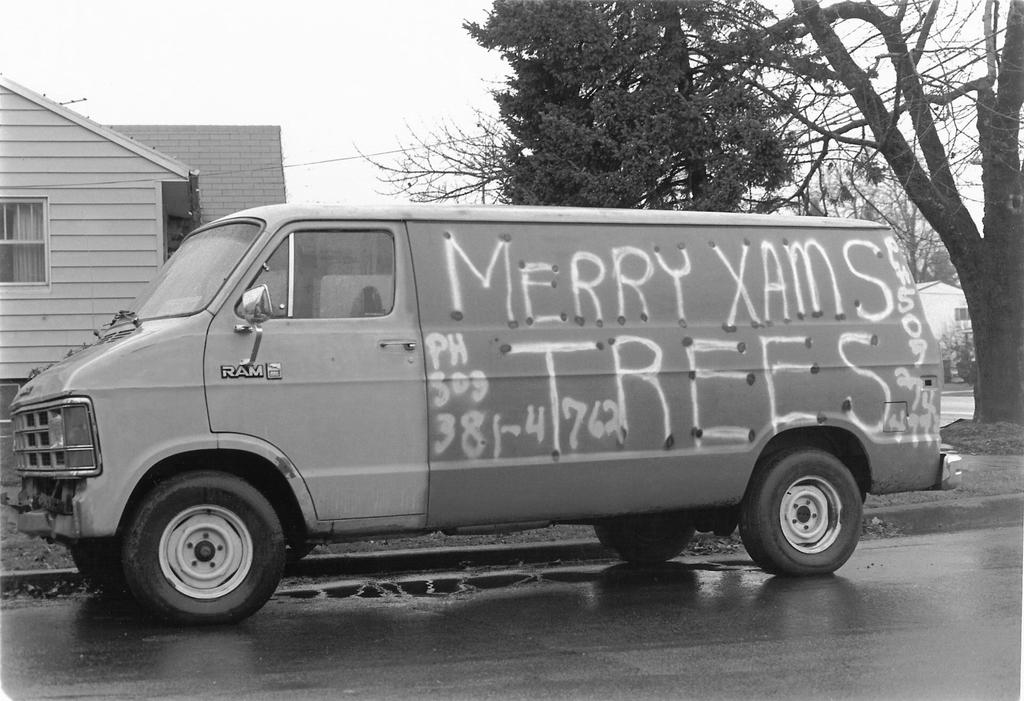What is the color scheme of the image? The image is black and white. What can be seen on the road in the image? There is a vehicle parked on the road. What structures are visible in the background of the image? There is a building, trees, and a house in the background. What part of the natural environment is visible in the image? The sky is visible in the image. Can you tell me how many frames are present in the image? There are no frames present in the image; it is a photograph or digital image without any visible frame. What type of toad can be seen hopping on the parked vehicle in the image? There is no toad present in the image; it only features a parked vehicle, a building, trees, a house, and the sky. 